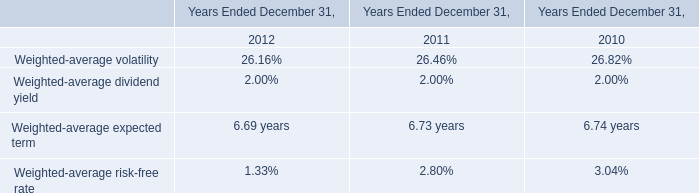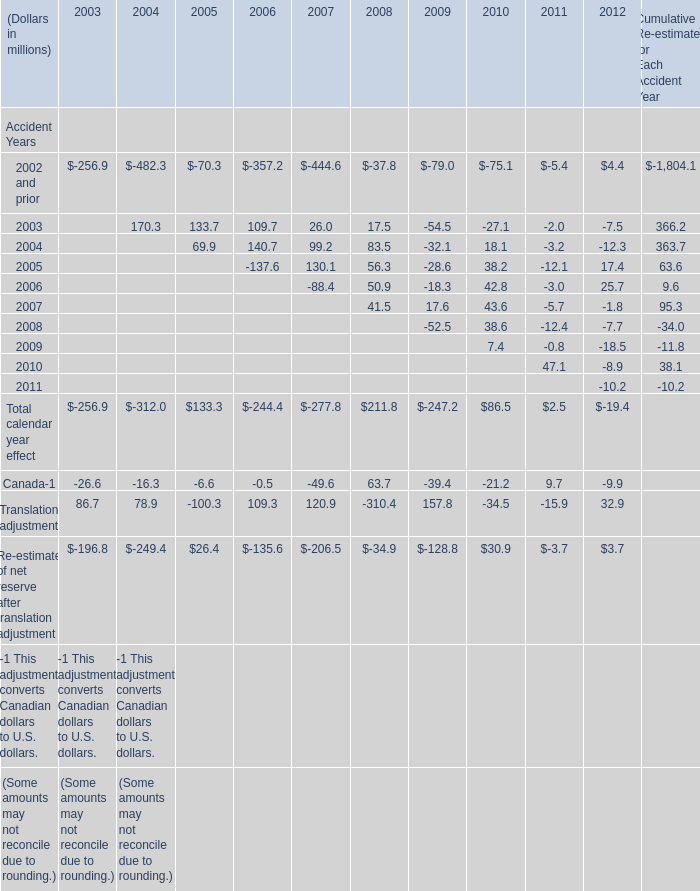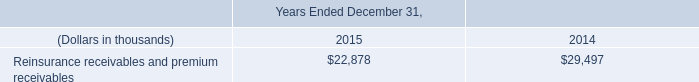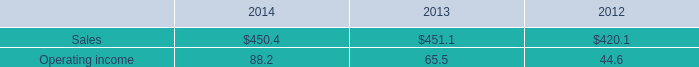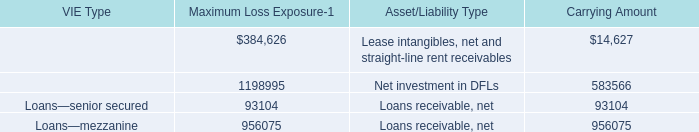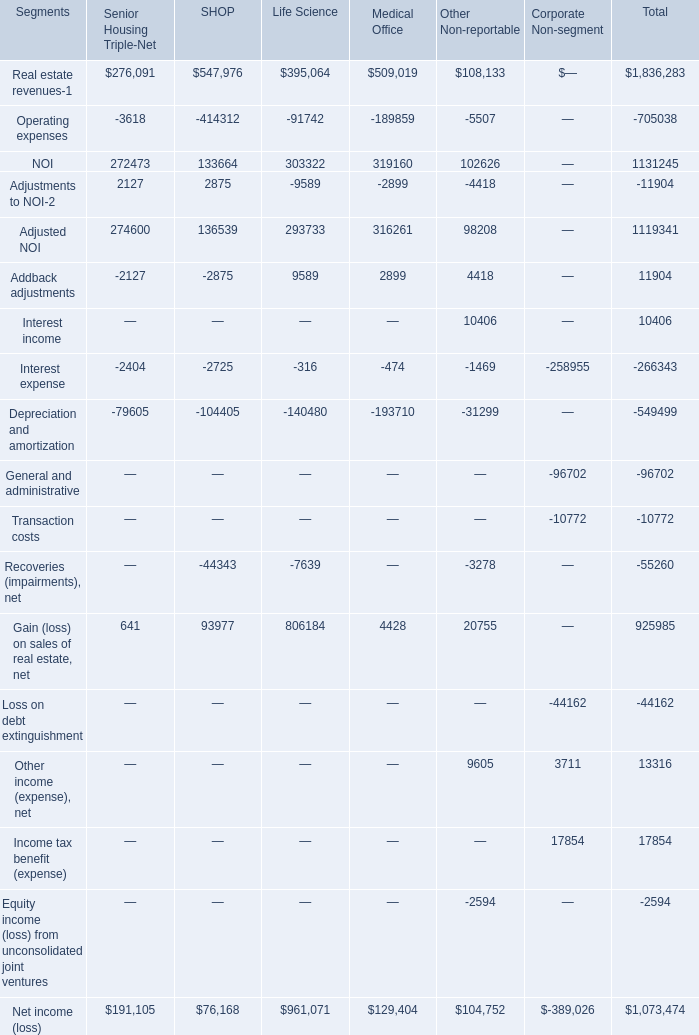What is the sum of Loans—senior secured of Maximum Loss Exposure, and Addback adjustments of SHOP ? 
Computations: (93104.0 + 2875.0)
Answer: 95979.0. 